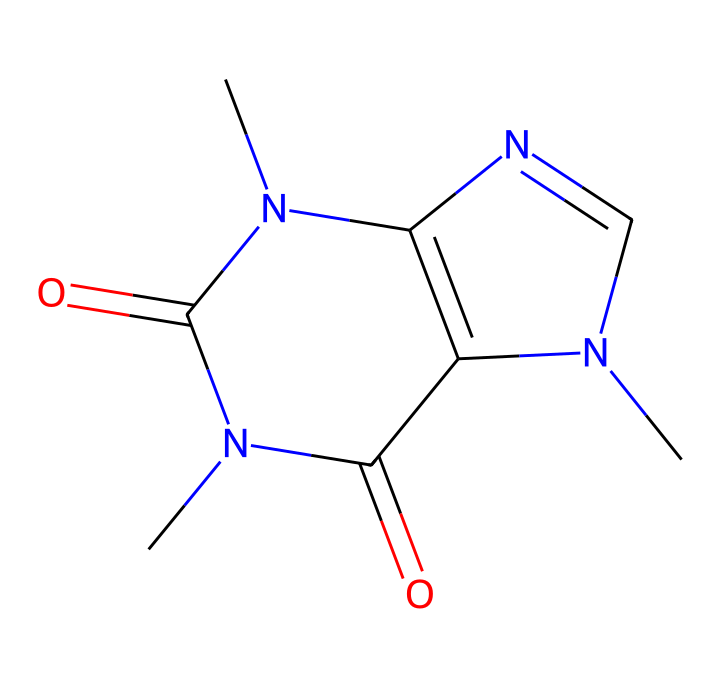What is the molecular formula of this chemical? The SMILES representation can be decoded to reveal the number of carbon (C), hydrogen (H), nitrogen (N), and oxygen (O) atoms. In this case, the breakdown shows there are 8 carbons, 10 hydrogens, 4 nitrogens, and 2 oxygens, leading to the molecular formula C8H10N4O2.
Answer: C8H10N4O2 How many rings are present in this chemical structure? By analyzing the SMILES, we see there are two 'N1' and 'N2' atoms indicating the presence of two cyclic structures. Therefore, we conclude that there are two rings.
Answer: 2 What kind of functional groups can be identified in this chemical? The provided SMILES indicates the presence of carbonyl (C=O) groups, as seen from the '=O' segments in the chemical structure. Additionally, the nitrogen atoms suggest the possible presence of amine functional groups.
Answer: carbonyl and amine Is this chemical considered to be a stimulant? Based on historical context and established knowledge, caffeine is classified as a stimulant due to its ability to enhance alertness and focus through its action on the central nervous system.
Answer: Yes What structural feature contributes to the bitter taste of this drug? The presence of nitrogen atoms in the chemical structure is typical for alkaloids, which are well-known to impart a bitter taste. The attachment of these nitrogen atoms likely plays a critical role in this sensation.
Answer: nitrogen atoms What is the primary effect of this chemical on literary creativity? Caffeine, as inferred from the structure, is associated with increased mental alertness and stimulated cognitive functions, which can enhance creativity, especially during writing or reading sessions.
Answer: increased creativity 